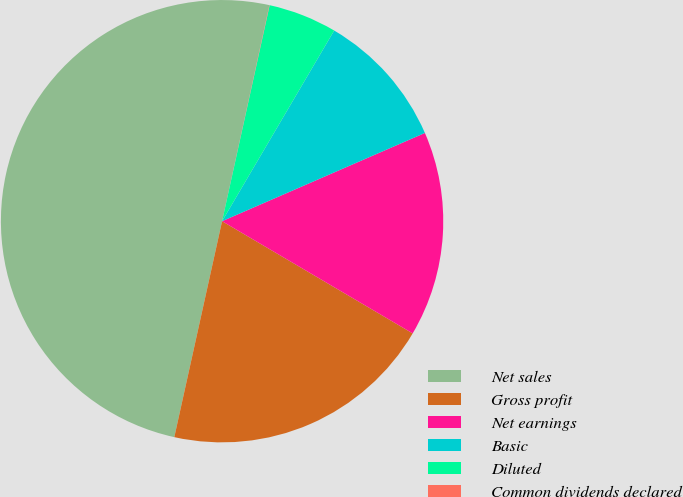Convert chart. <chart><loc_0><loc_0><loc_500><loc_500><pie_chart><fcel>Net sales<fcel>Gross profit<fcel>Net earnings<fcel>Basic<fcel>Diluted<fcel>Common dividends declared<nl><fcel>49.97%<fcel>20.0%<fcel>15.0%<fcel>10.01%<fcel>5.01%<fcel>0.02%<nl></chart> 